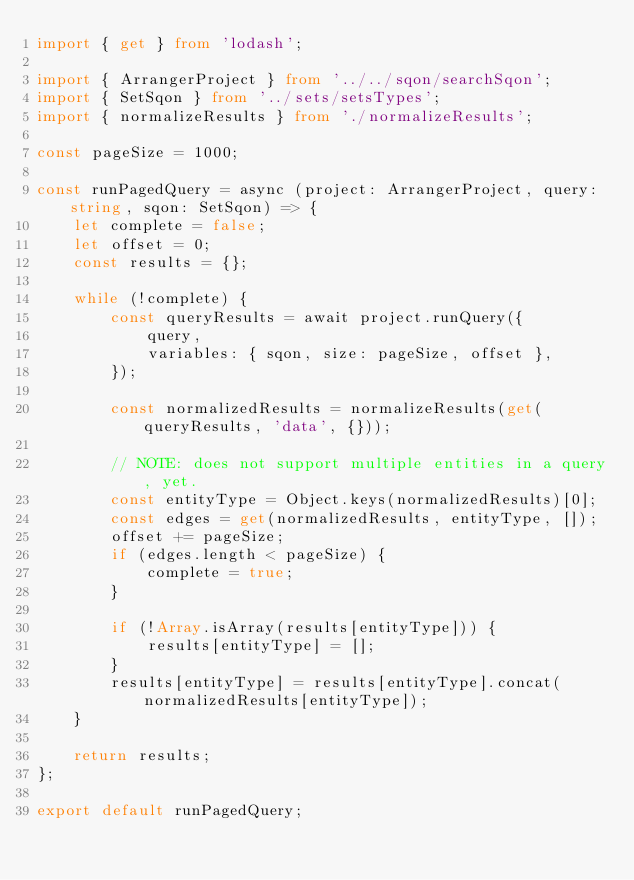<code> <loc_0><loc_0><loc_500><loc_500><_TypeScript_>import { get } from 'lodash';

import { ArrangerProject } from '../../sqon/searchSqon';
import { SetSqon } from '../sets/setsTypes';
import { normalizeResults } from './normalizeResults';

const pageSize = 1000;

const runPagedQuery = async (project: ArrangerProject, query: string, sqon: SetSqon) => {
    let complete = false;
    let offset = 0;
    const results = {};

    while (!complete) {
        const queryResults = await project.runQuery({
            query,
            variables: { sqon, size: pageSize, offset },
        });

        const normalizedResults = normalizeResults(get(queryResults, 'data', {}));

        // NOTE: does not support multiple entities in a query, yet.
        const entityType = Object.keys(normalizedResults)[0];
        const edges = get(normalizedResults, entityType, []);
        offset += pageSize;
        if (edges.length < pageSize) {
            complete = true;
        }

        if (!Array.isArray(results[entityType])) {
            results[entityType] = [];
        }
        results[entityType] = results[entityType].concat(normalizedResults[entityType]);
    }

    return results;
};

export default runPagedQuery;
</code> 